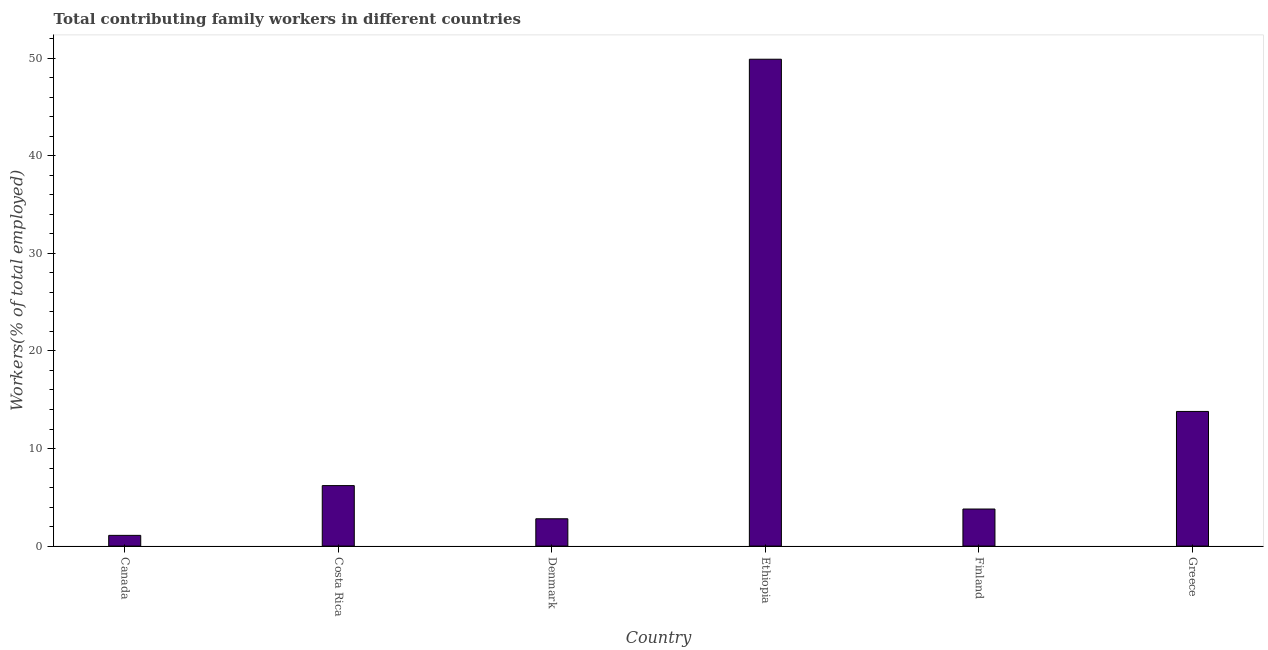Does the graph contain grids?
Offer a terse response. No. What is the title of the graph?
Provide a succinct answer. Total contributing family workers in different countries. What is the label or title of the Y-axis?
Give a very brief answer. Workers(% of total employed). What is the contributing family workers in Costa Rica?
Your answer should be compact. 6.2. Across all countries, what is the maximum contributing family workers?
Offer a very short reply. 49.9. Across all countries, what is the minimum contributing family workers?
Provide a short and direct response. 1.1. In which country was the contributing family workers maximum?
Offer a very short reply. Ethiopia. In which country was the contributing family workers minimum?
Offer a terse response. Canada. What is the sum of the contributing family workers?
Offer a terse response. 77.6. What is the difference between the contributing family workers in Canada and Ethiopia?
Keep it short and to the point. -48.8. What is the average contributing family workers per country?
Keep it short and to the point. 12.93. What is the median contributing family workers?
Your answer should be very brief. 5. In how many countries, is the contributing family workers greater than 8 %?
Your response must be concise. 2. What is the ratio of the contributing family workers in Costa Rica to that in Greece?
Make the answer very short. 0.45. What is the difference between the highest and the second highest contributing family workers?
Your answer should be compact. 36.1. What is the difference between the highest and the lowest contributing family workers?
Make the answer very short. 48.8. In how many countries, is the contributing family workers greater than the average contributing family workers taken over all countries?
Provide a succinct answer. 2. What is the difference between two consecutive major ticks on the Y-axis?
Your answer should be very brief. 10. Are the values on the major ticks of Y-axis written in scientific E-notation?
Provide a succinct answer. No. What is the Workers(% of total employed) in Canada?
Your answer should be compact. 1.1. What is the Workers(% of total employed) of Costa Rica?
Your response must be concise. 6.2. What is the Workers(% of total employed) in Denmark?
Keep it short and to the point. 2.8. What is the Workers(% of total employed) in Ethiopia?
Your answer should be very brief. 49.9. What is the Workers(% of total employed) in Finland?
Give a very brief answer. 3.8. What is the Workers(% of total employed) of Greece?
Provide a short and direct response. 13.8. What is the difference between the Workers(% of total employed) in Canada and Ethiopia?
Provide a succinct answer. -48.8. What is the difference between the Workers(% of total employed) in Canada and Finland?
Make the answer very short. -2.7. What is the difference between the Workers(% of total employed) in Canada and Greece?
Ensure brevity in your answer.  -12.7. What is the difference between the Workers(% of total employed) in Costa Rica and Ethiopia?
Offer a terse response. -43.7. What is the difference between the Workers(% of total employed) in Costa Rica and Greece?
Ensure brevity in your answer.  -7.6. What is the difference between the Workers(% of total employed) in Denmark and Ethiopia?
Give a very brief answer. -47.1. What is the difference between the Workers(% of total employed) in Denmark and Finland?
Your response must be concise. -1. What is the difference between the Workers(% of total employed) in Ethiopia and Finland?
Provide a succinct answer. 46.1. What is the difference between the Workers(% of total employed) in Ethiopia and Greece?
Provide a short and direct response. 36.1. What is the ratio of the Workers(% of total employed) in Canada to that in Costa Rica?
Your answer should be very brief. 0.18. What is the ratio of the Workers(% of total employed) in Canada to that in Denmark?
Keep it short and to the point. 0.39. What is the ratio of the Workers(% of total employed) in Canada to that in Ethiopia?
Offer a very short reply. 0.02. What is the ratio of the Workers(% of total employed) in Canada to that in Finland?
Offer a very short reply. 0.29. What is the ratio of the Workers(% of total employed) in Canada to that in Greece?
Your response must be concise. 0.08. What is the ratio of the Workers(% of total employed) in Costa Rica to that in Denmark?
Ensure brevity in your answer.  2.21. What is the ratio of the Workers(% of total employed) in Costa Rica to that in Ethiopia?
Ensure brevity in your answer.  0.12. What is the ratio of the Workers(% of total employed) in Costa Rica to that in Finland?
Provide a short and direct response. 1.63. What is the ratio of the Workers(% of total employed) in Costa Rica to that in Greece?
Offer a terse response. 0.45. What is the ratio of the Workers(% of total employed) in Denmark to that in Ethiopia?
Your answer should be very brief. 0.06. What is the ratio of the Workers(% of total employed) in Denmark to that in Finland?
Keep it short and to the point. 0.74. What is the ratio of the Workers(% of total employed) in Denmark to that in Greece?
Provide a short and direct response. 0.2. What is the ratio of the Workers(% of total employed) in Ethiopia to that in Finland?
Offer a terse response. 13.13. What is the ratio of the Workers(% of total employed) in Ethiopia to that in Greece?
Offer a very short reply. 3.62. What is the ratio of the Workers(% of total employed) in Finland to that in Greece?
Provide a short and direct response. 0.28. 